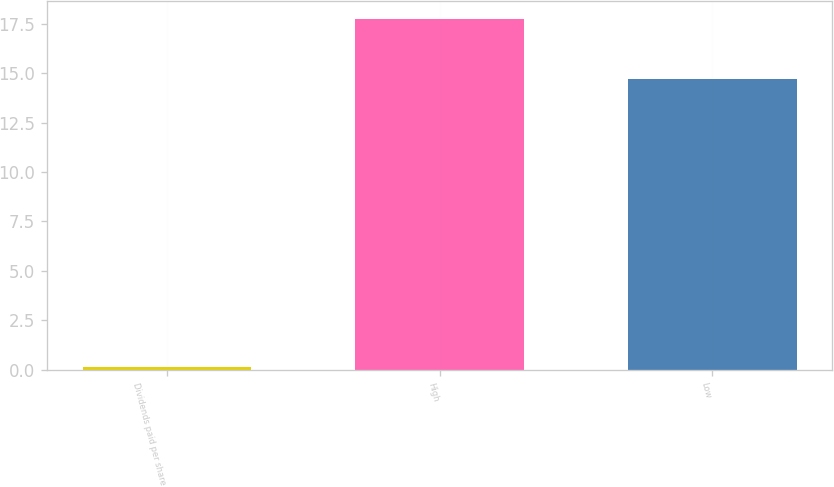Convert chart to OTSL. <chart><loc_0><loc_0><loc_500><loc_500><bar_chart><fcel>Dividends paid per share<fcel>High<fcel>Low<nl><fcel>0.15<fcel>17.75<fcel>14.68<nl></chart> 